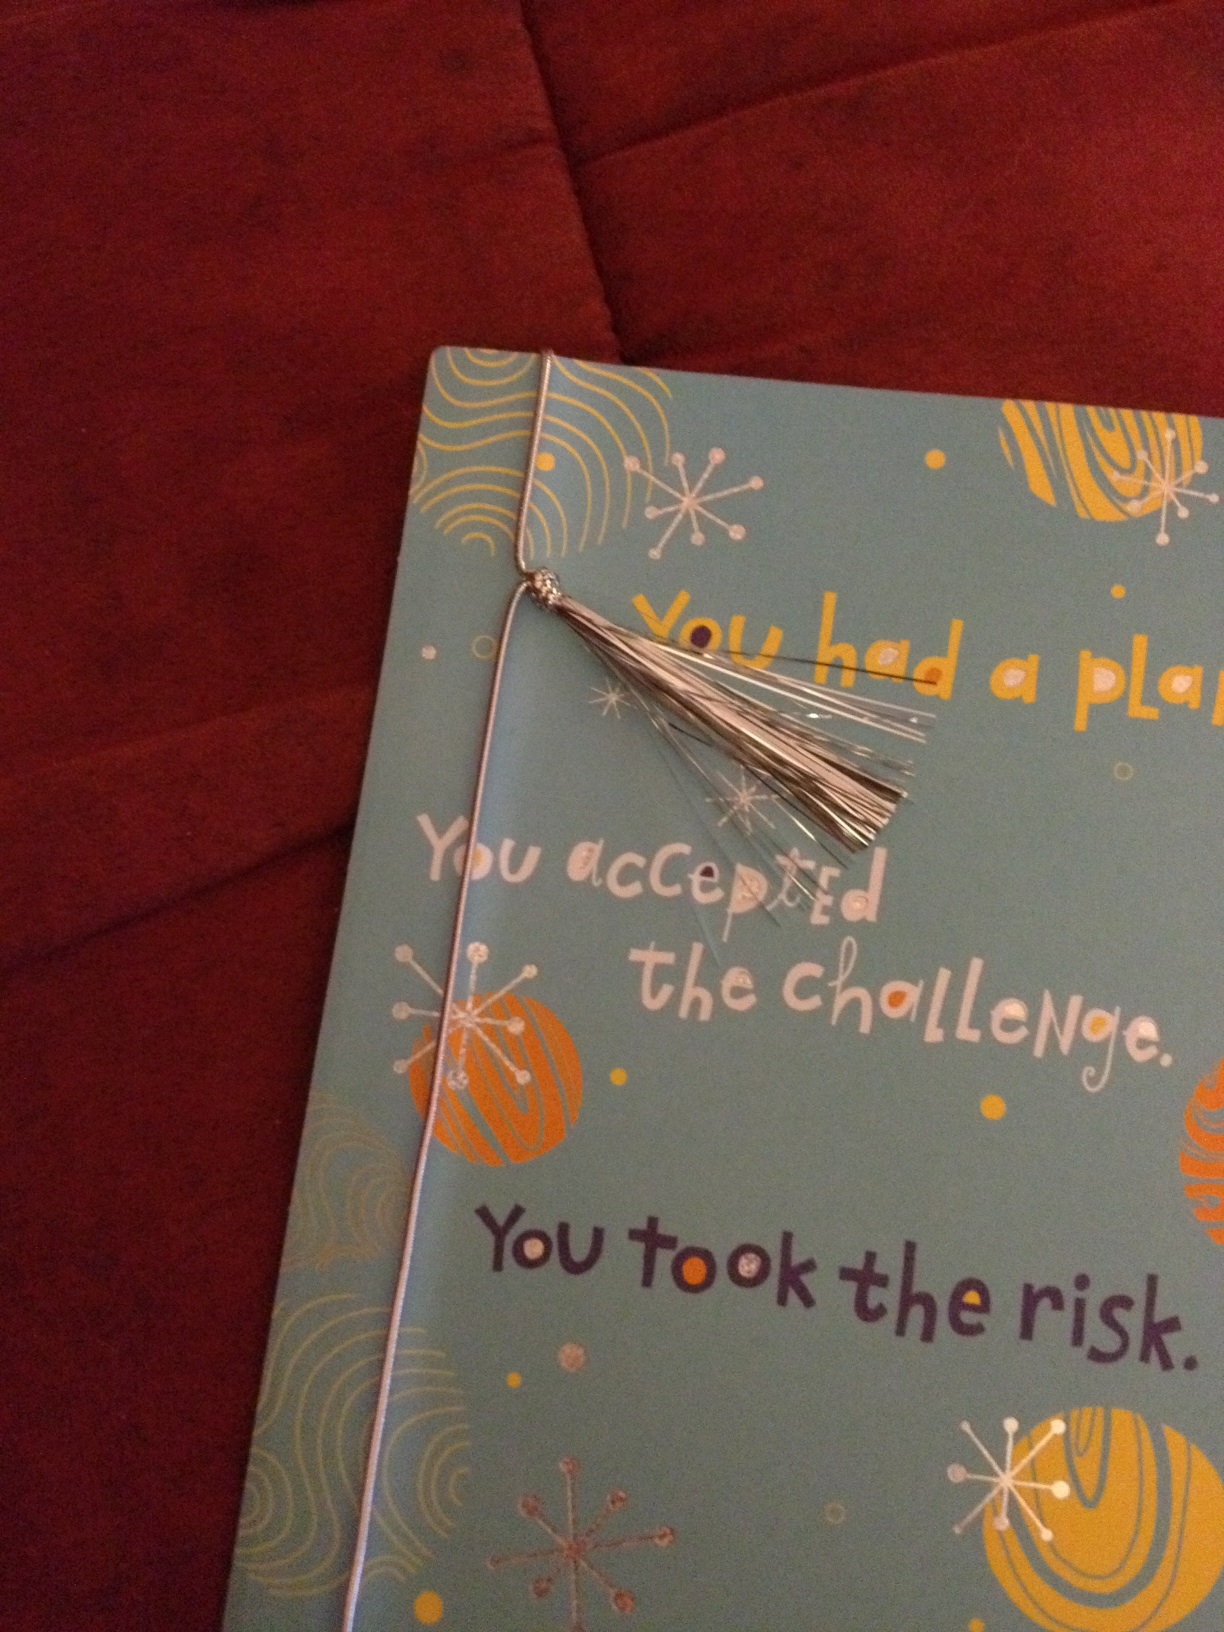What imaginative story could be associated with the design and message of this card? Once upon a time in a vibrant kingdom, there was a brave young knight named Aria. Despite her small stature and humble beginnings, she dreamed of achieving greatness. One day, the kingdom was threatened by a powerful adversary, and Aria was determined to protect her homeland. With a detailed plan, she accepted the challenge and embarked on a perilous journey. Along the way, she faced dragons, scaled towering cliffs, and navigated through dark enchanted forests. With her courage and determination, she overcame every obstacle. Upon her return, the kingdom celebrated her bravery and valor. In recognition of her immense effort and success, the king presented her with a special keepsake – a card adorned with the words: 'You had a plan. You accepted the challenge. You took the risk.' This card, embellished with colorful designs and a silver tassel, symbolized her journey and victory. Aria kept the card as a reminder that with courage and determination, any challenge could be conquered. 